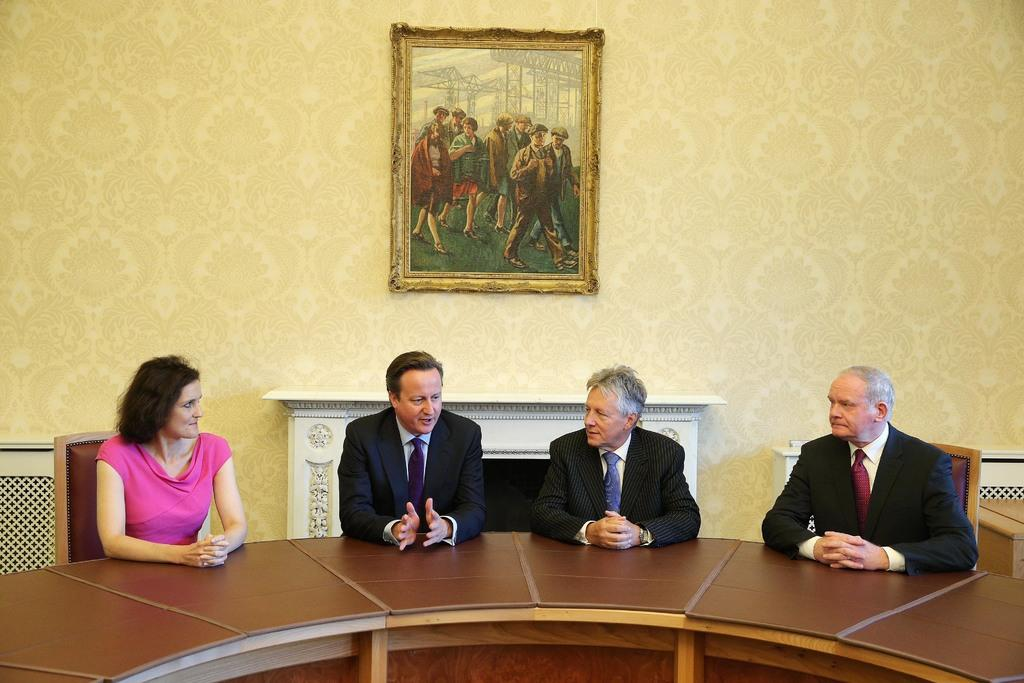How many people are in the image? There are four people in the image: three men and one woman. What are the people doing in the image? The people are sitting on chairs and talking. What is in front of the people? They are in front of a table. What can be seen on the wall in the image? There is a beautiful frame on the wall. What type of chess piece is the woman holding in the image? There is no chess piece present in the image; the people are sitting and talking. 